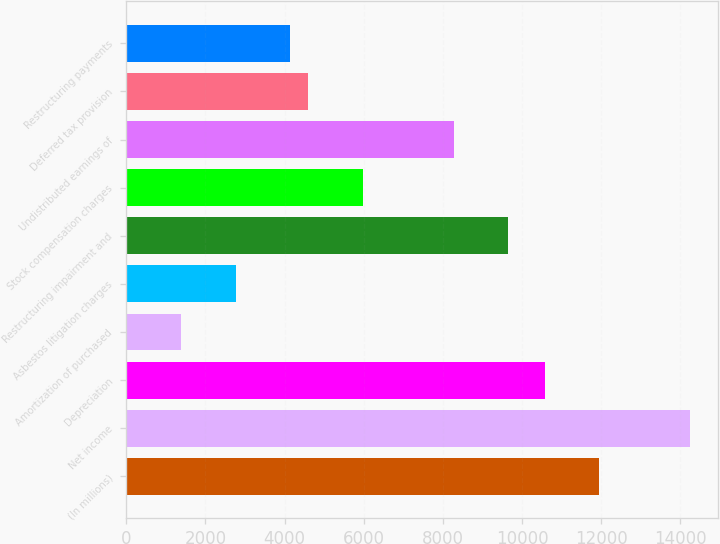<chart> <loc_0><loc_0><loc_500><loc_500><bar_chart><fcel>(In millions)<fcel>Net income<fcel>Depreciation<fcel>Amortization of purchased<fcel>Asbestos litigation charges<fcel>Restructuring impairment and<fcel>Stock compensation charges<fcel>Undistributed earnings of<fcel>Deferred tax provision<fcel>Restructuring payments<nl><fcel>11953.2<fcel>14251.7<fcel>10574.1<fcel>1380.1<fcel>2759.2<fcel>9654.7<fcel>5977.1<fcel>8275.6<fcel>4598<fcel>4138.3<nl></chart> 